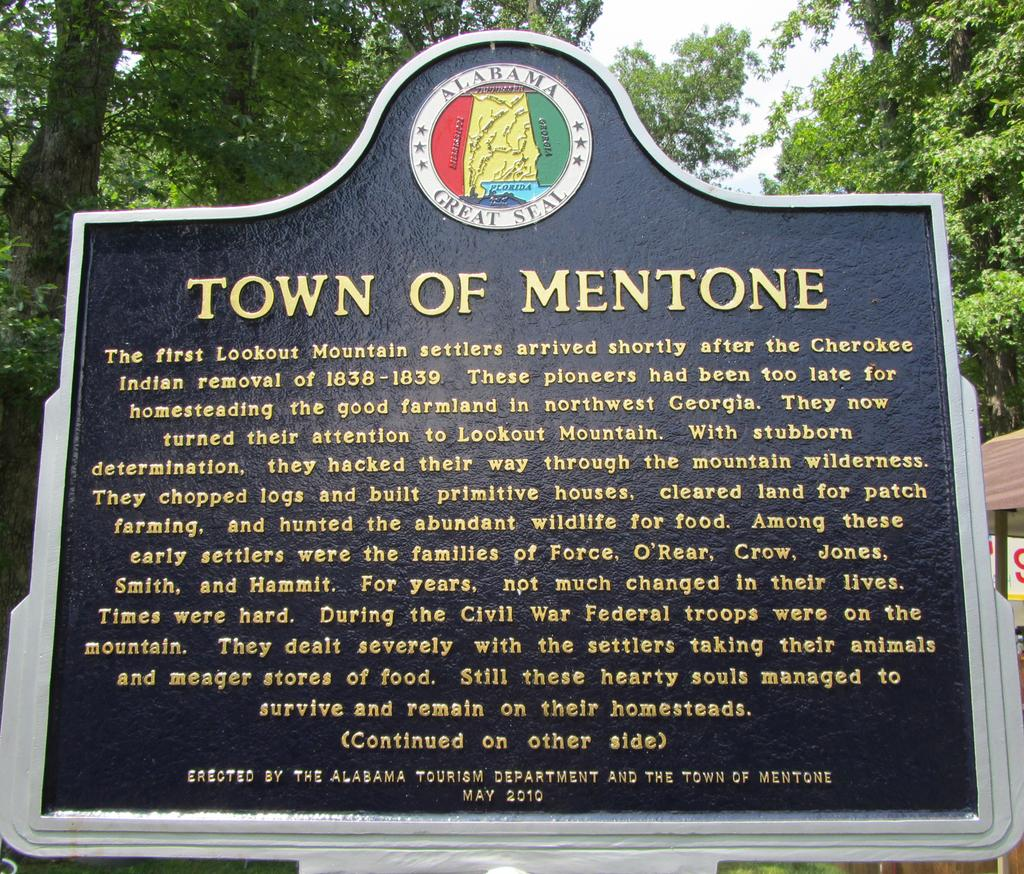What is the main subject of the image? There is a memorial stone in the image. What can be seen in the background of the image? There are trees in the background of the image. What structure is located on the right side of the image? There is a small tent on the right side of the image. What type of fruit is being served at the feast in the image? There is no feast present in the image, so it is not possible to determine what type of fruit might be served. 